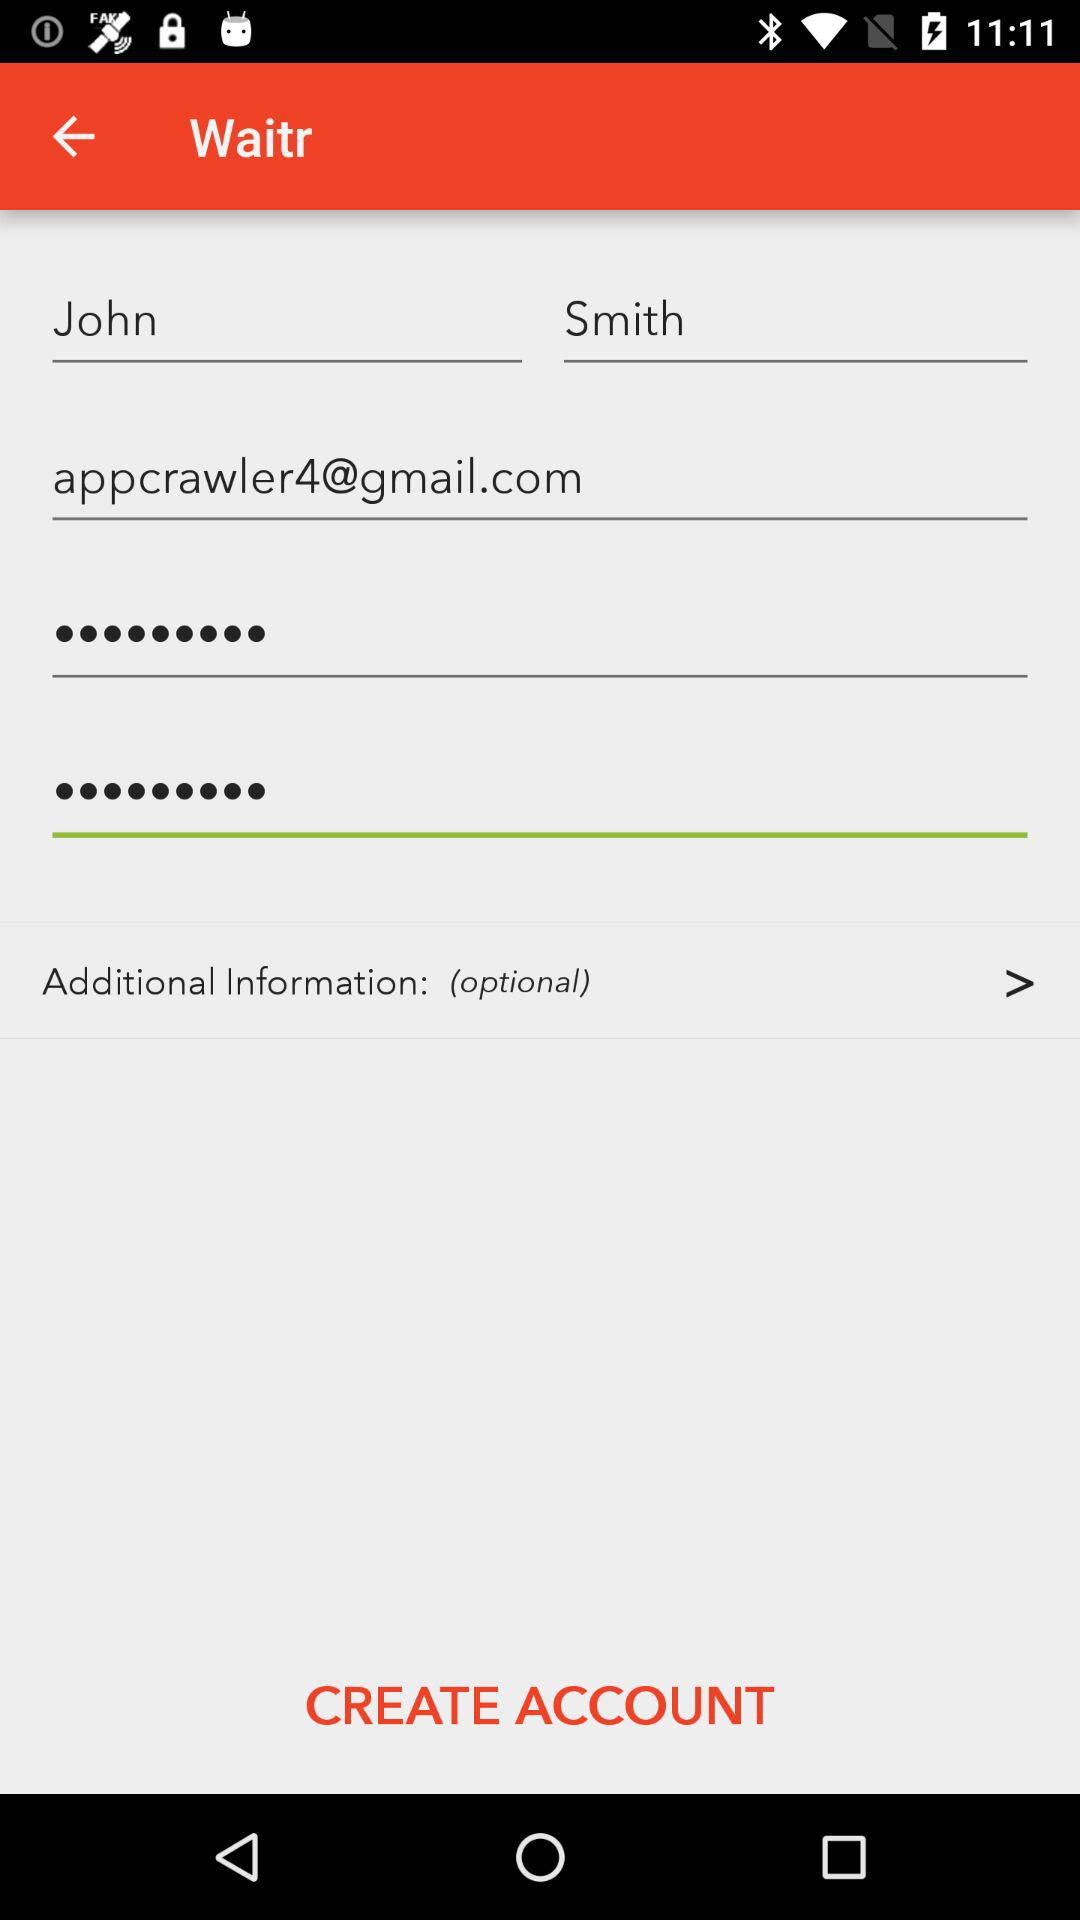Is the password considered to be a strong password?
When the provided information is insufficient, respond with <no answer>. <no answer> 